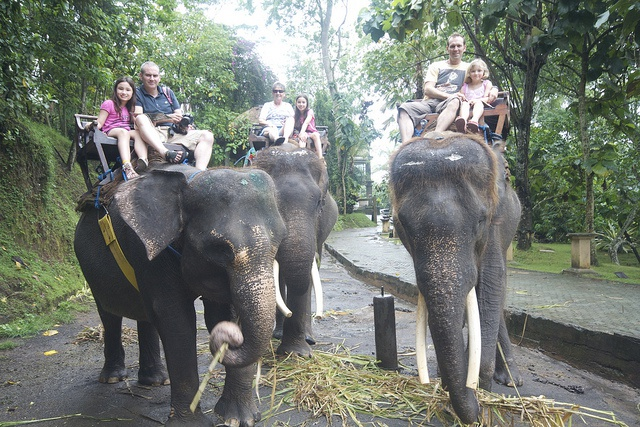Describe the objects in this image and their specific colors. I can see elephant in green, black, gray, and darkgray tones, elephant in green, gray, darkgray, white, and black tones, elephant in green, gray, darkgray, lightgray, and black tones, people in green, white, darkgray, and gray tones, and people in green, white, gray, and darkgray tones in this image. 